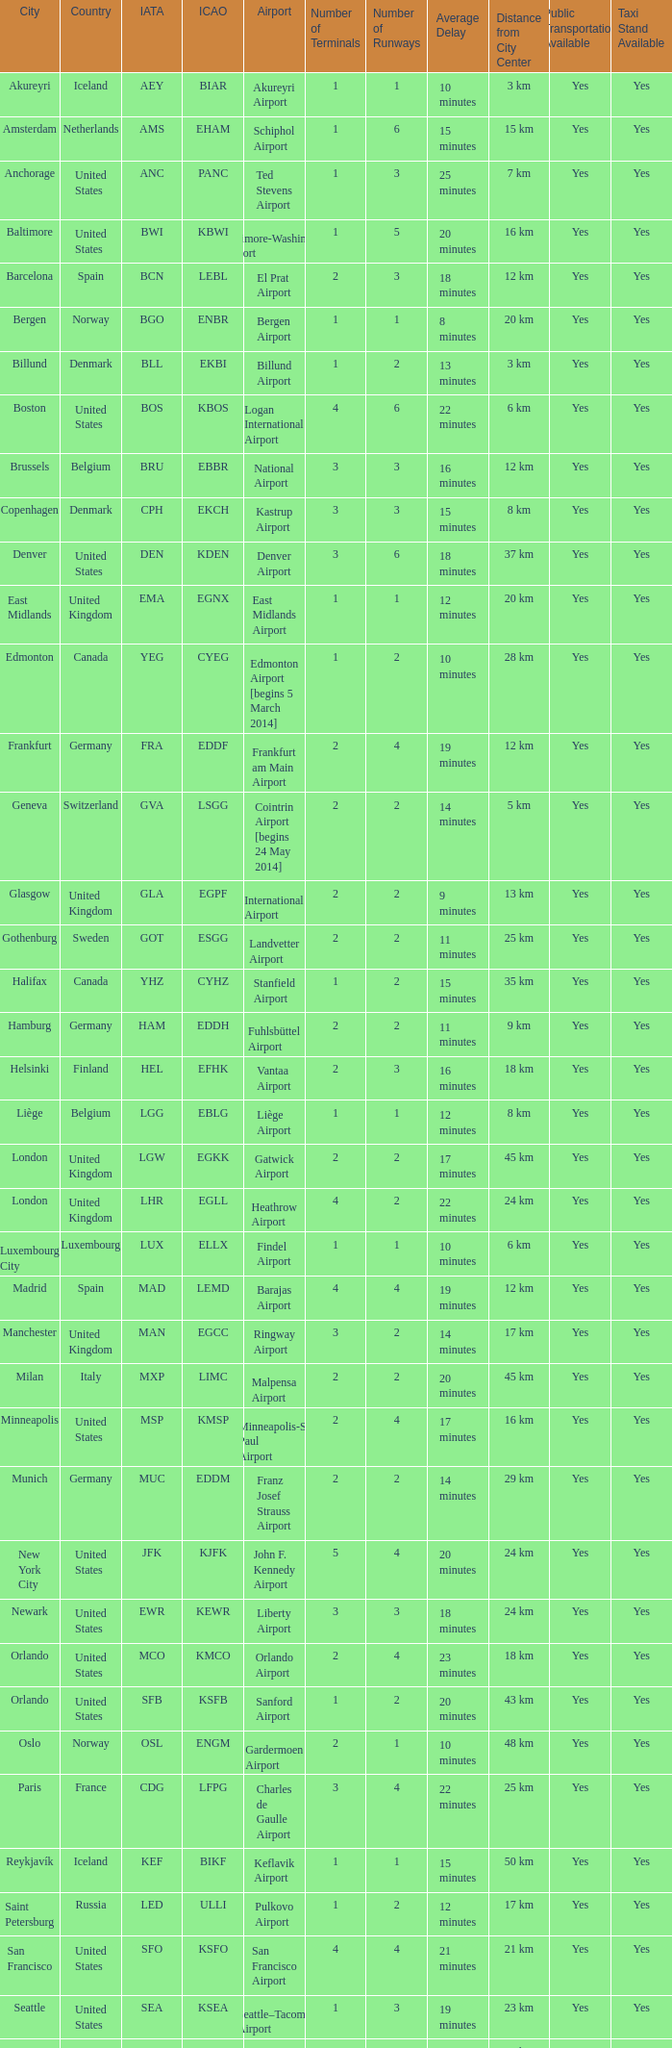What Airport's IATA is SEA? Seattle–Tacoma Airport. 